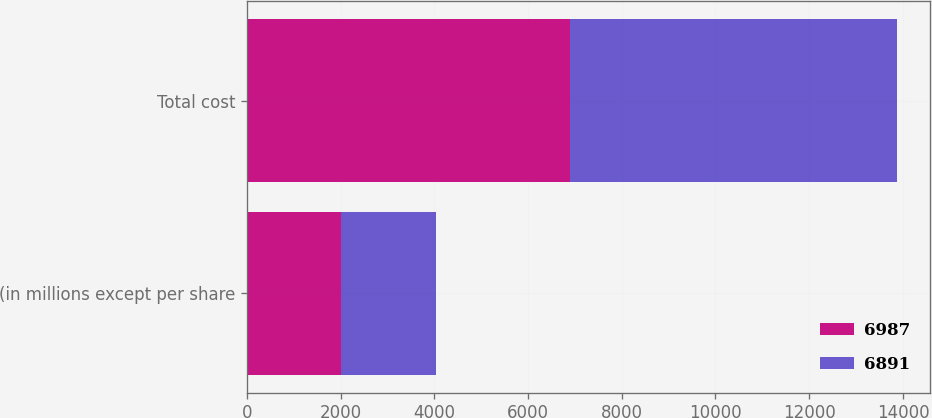Convert chart to OTSL. <chart><loc_0><loc_0><loc_500><loc_500><stacked_bar_chart><ecel><fcel>(in millions except per share<fcel>Total cost<nl><fcel>6987<fcel>2017<fcel>6891<nl><fcel>6891<fcel>2016<fcel>6987<nl></chart> 